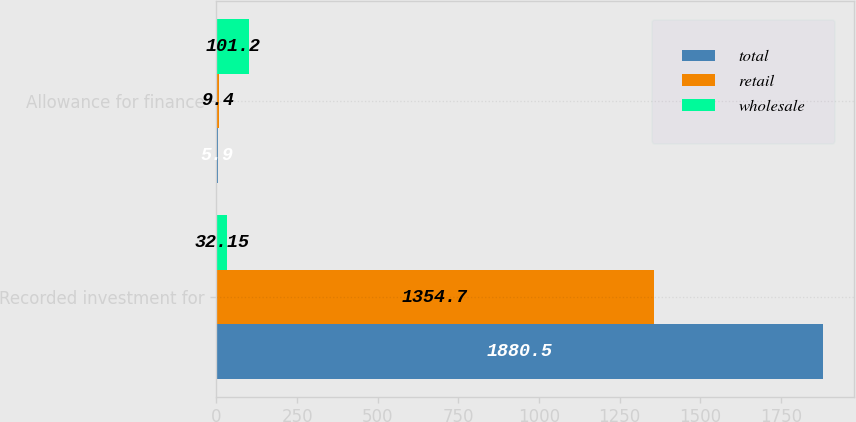<chart> <loc_0><loc_0><loc_500><loc_500><stacked_bar_chart><ecel><fcel>Recorded investment for<fcel>Allowance for finance<nl><fcel>total<fcel>1880.5<fcel>5.9<nl><fcel>retail<fcel>1354.7<fcel>9.4<nl><fcel>wholesale<fcel>32.15<fcel>101.2<nl></chart> 